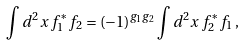<formula> <loc_0><loc_0><loc_500><loc_500>\int d ^ { 2 } x \, f _ { 1 } ^ { * } f _ { 2 } = ( - 1 ) ^ { g _ { 1 } g _ { 2 } } \int d ^ { 2 } x \, f _ { 2 } ^ { * } f _ { 1 } \, ,</formula> 